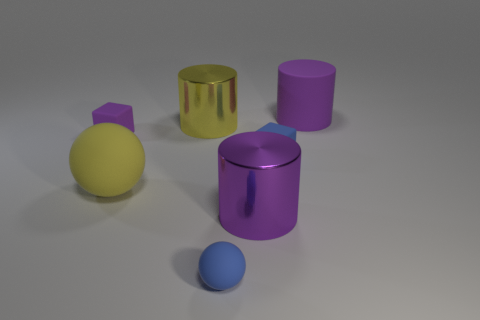There is a metallic cylinder that is on the right side of the small sphere; is its color the same as the tiny rubber ball?
Give a very brief answer. No. Are there an equal number of big purple shiny objects behind the tiny blue rubber cube and big shiny cylinders behind the big matte cylinder?
Your answer should be very brief. Yes. Is there any other thing that is made of the same material as the blue cube?
Provide a succinct answer. Yes. There is a big cylinder that is on the left side of the purple metallic cylinder; what is its color?
Offer a terse response. Yellow. Are there the same number of blue spheres in front of the small purple block and big metal cylinders?
Your answer should be very brief. No. How many other things are the same shape as the large purple metallic object?
Provide a succinct answer. 2. How many big purple objects are behind the big yellow cylinder?
Keep it short and to the point. 1. What is the size of the cylinder that is right of the large yellow cylinder and in front of the purple matte cylinder?
Your answer should be very brief. Large. Is there a tiny shiny sphere?
Provide a succinct answer. No. What number of other objects are there of the same size as the purple shiny cylinder?
Offer a very short reply. 3. 